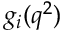<formula> <loc_0><loc_0><loc_500><loc_500>g _ { i } ( q ^ { 2 } )</formula> 